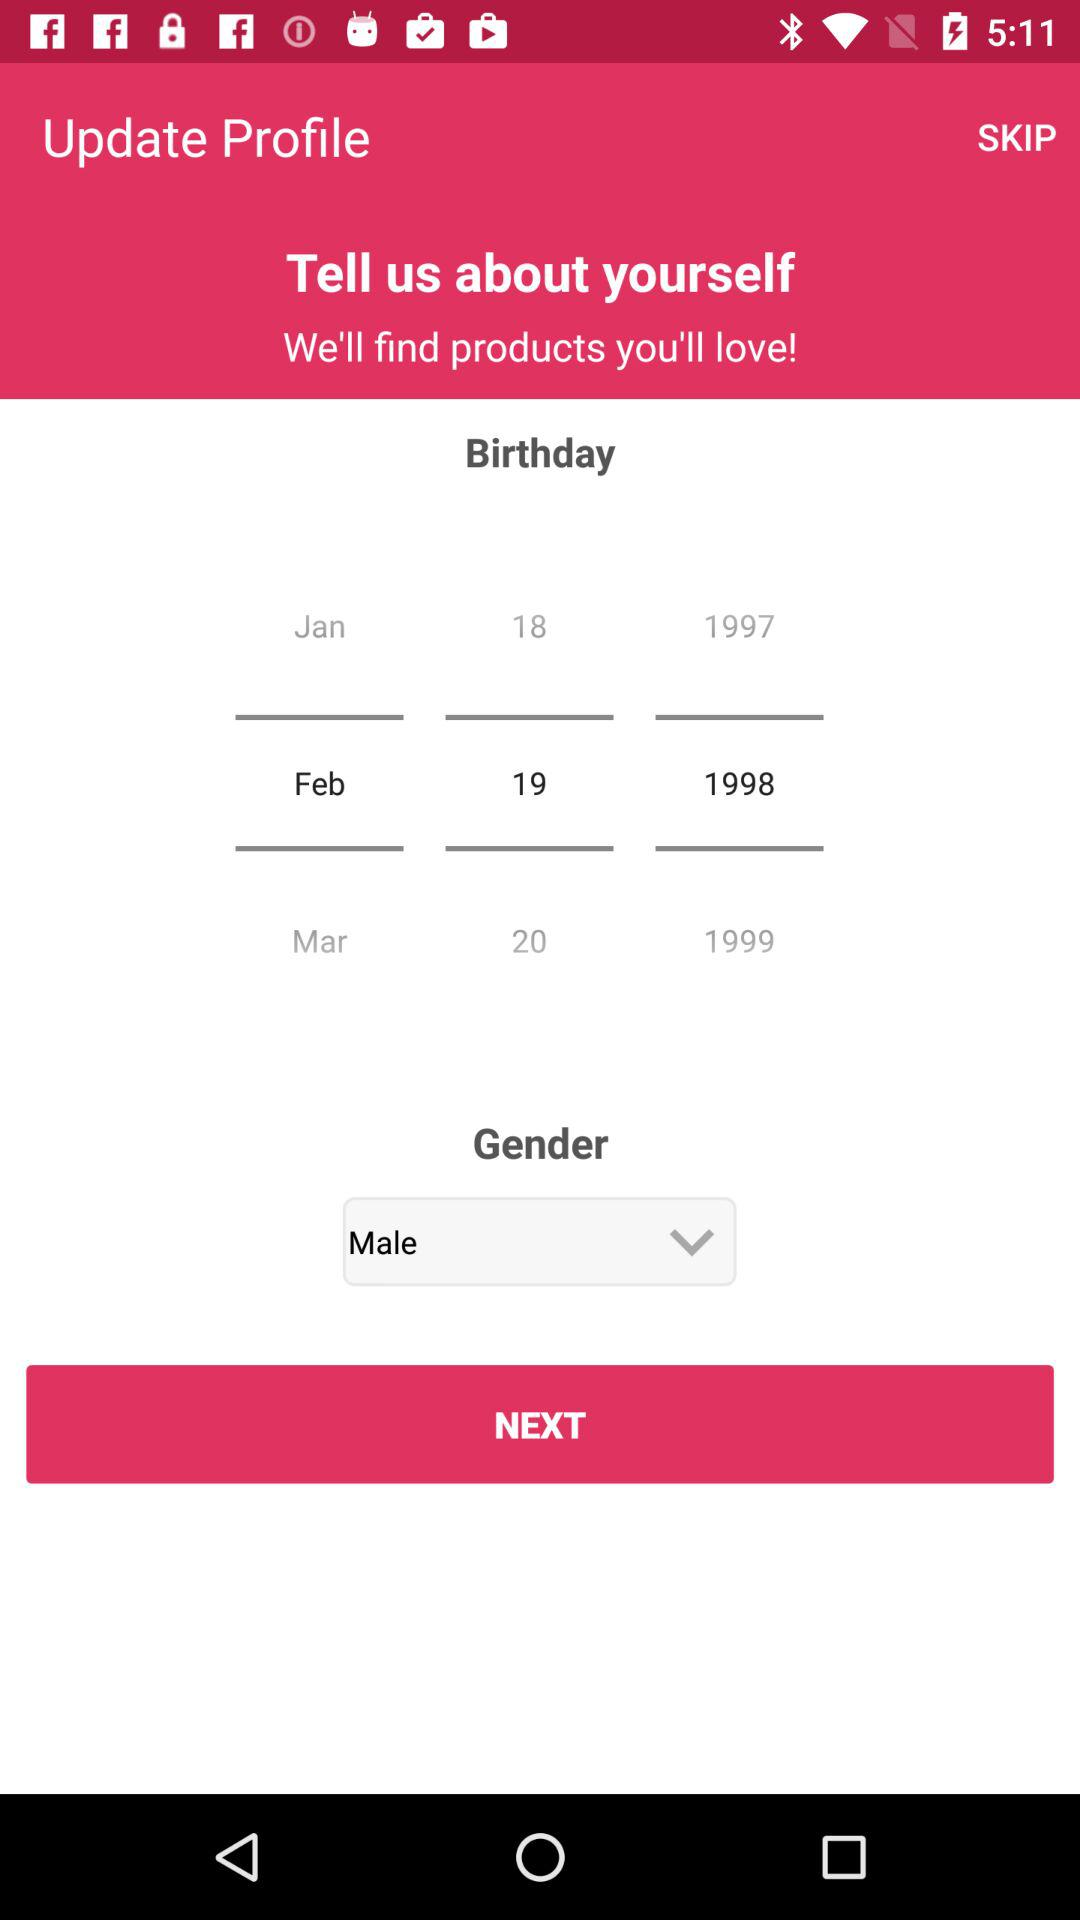What is the birthday date? The birthday date is February 19, 1998. 